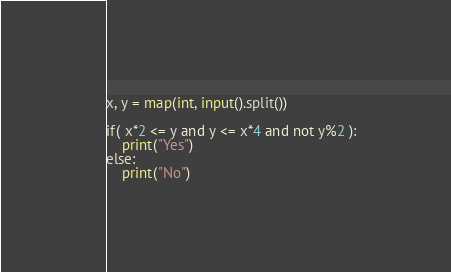Convert code to text. <code><loc_0><loc_0><loc_500><loc_500><_Python_>x, y = map(int, input().split())

if( x*2 <= y and y <= x*4 and not y%2 ):
    print("Yes")
else:
    print("No")</code> 